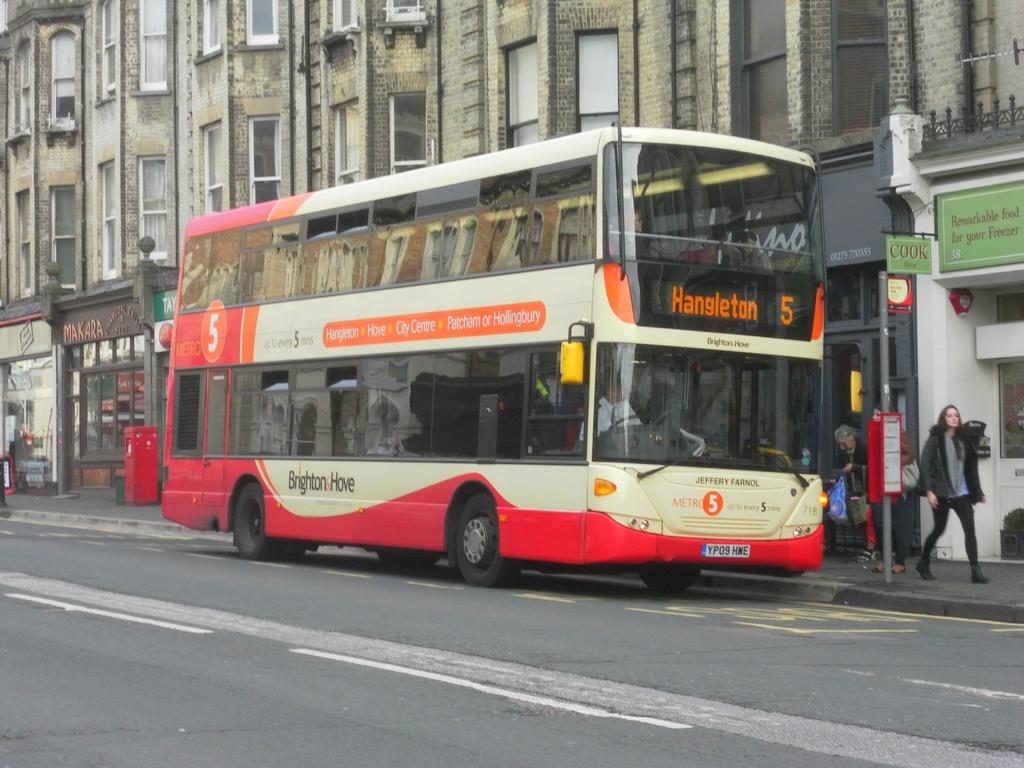What type of vehicle is on the road in the image? There is a bus on the road in the image. What can be seen on the pavement? There are people on the pavement. What is attached to the pole in the image? There is a board on the pole in the image. What is present on the buildings in the image? There are boards on the buildings in the image. What color is the box in the background? There is a red color box in the background. What type of spring is visible in the image? There is no spring present in the image. What kind of notebook is being used by the people on the pavement? There is no notebook visible in the image. 